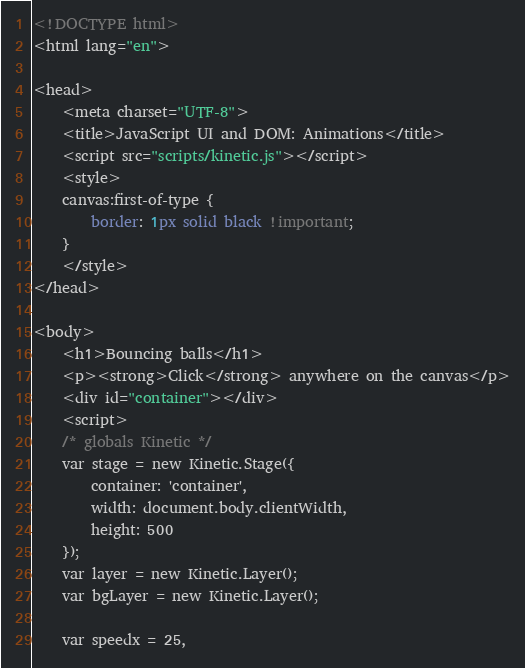<code> <loc_0><loc_0><loc_500><loc_500><_HTML_><!DOCTYPE html>
<html lang="en">

<head>
    <meta charset="UTF-8">
    <title>JavaScript UI and DOM: Animations</title>
    <script src="scripts/kinetic.js"></script>
    <style>
    canvas:first-of-type {
        border: 1px solid black !important;
    }
    </style>
</head>

<body>
    <h1>Bouncing balls</h1>
    <p><strong>Click</strong> anywhere on the canvas</p>
    <div id="container"></div>
    <script>
    /* globals Kinetic */
    var stage = new Kinetic.Stage({
        container: 'container',
        width: document.body.clientWidth,
        height: 500
    });
    var layer = new Kinetic.Layer();
    var bgLayer = new Kinetic.Layer();

    var speedx = 25,</code> 